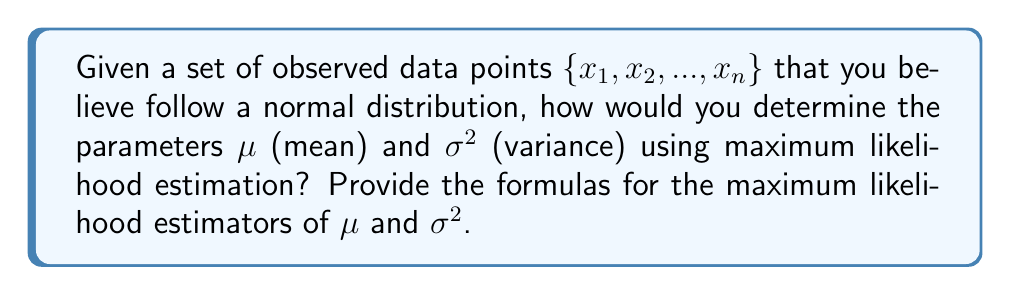Help me with this question. To determine the parameters $\mu$ and $\sigma^2$ of a normal distribution using maximum likelihood estimation (MLE), we follow these steps:

1. Write the probability density function (PDF) of the normal distribution:
   $$f(x|\mu,\sigma^2) = \frac{1}{\sqrt{2\pi\sigma^2}} e^{-\frac{(x-\mu)^2}{2\sigma^2}}$$

2. Construct the likelihood function for $n$ independent observations:
   $$L(\mu,\sigma^2|x_1,...,x_n) = \prod_{i=1}^n f(x_i|\mu,\sigma^2)$$

3. Take the natural logarithm of the likelihood function to get the log-likelihood:
   $$\ln L(\mu,\sigma^2|x_1,...,x_n) = -\frac{n}{2}\ln(2\pi\sigma^2) - \frac{1}{2\sigma^2}\sum_{i=1}^n (x_i-\mu)^2$$

4. To find the maximum likelihood estimators, we differentiate the log-likelihood with respect to $\mu$ and $\sigma^2$ and set the derivatives to zero:

   For $\mu$:
   $$\frac{\partial \ln L}{\partial \mu} = \frac{1}{\sigma^2}\sum_{i=1}^n (x_i-\mu) = 0$$

   For $\sigma^2$:
   $$\frac{\partial \ln L}{\partial \sigma^2} = -\frac{n}{2\sigma^2} + \frac{1}{2(\sigma^2)^2}\sum_{i=1}^n (x_i-\mu)^2 = 0$$

5. Solve these equations to get the maximum likelihood estimators:

   For $\mu$:
   $$\hat{\mu}_{MLE} = \frac{1}{n}\sum_{i=1}^n x_i$$

   For $\sigma^2$:
   $$\hat{\sigma}^2_{MLE} = \frac{1}{n}\sum_{i=1}^n (x_i-\hat{\mu}_{MLE})^2$$

These formulas provide the maximum likelihood estimators for the mean and variance of a normal distribution given a set of observed data points.
Answer: $\hat{\mu}_{MLE} = \frac{1}{n}\sum_{i=1}^n x_i$, $\hat{\sigma}^2_{MLE} = \frac{1}{n}\sum_{i=1}^n (x_i-\hat{\mu}_{MLE})^2$ 